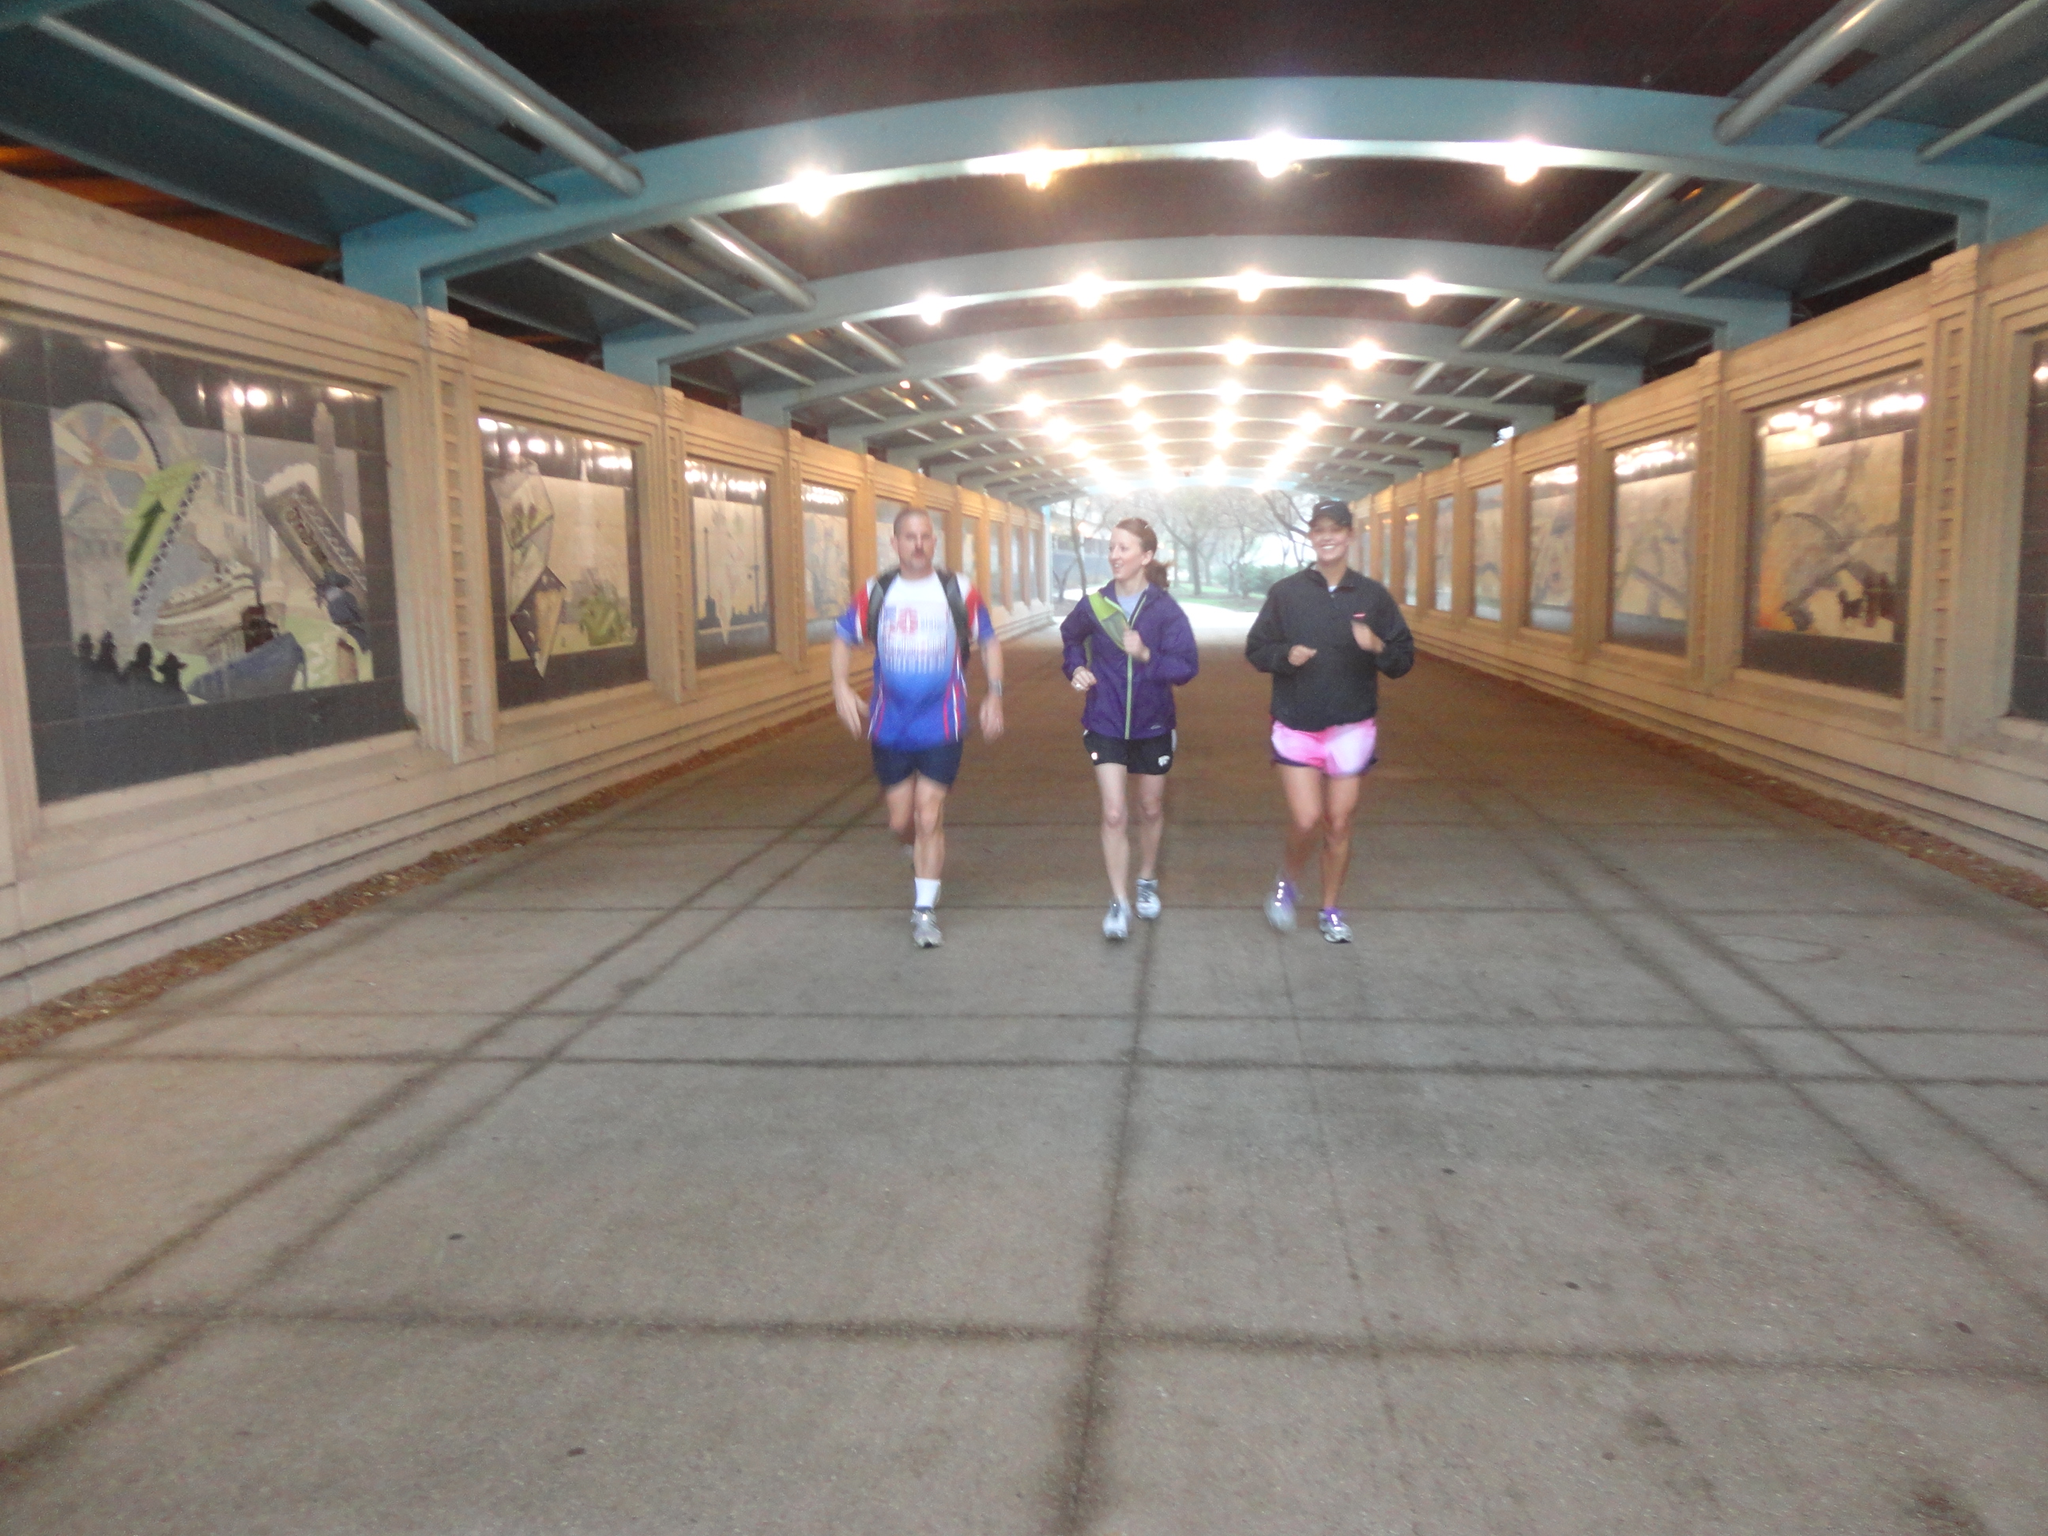In one or two sentences, can you explain what this image depicts? In this image we can see the people running on the ground and the other person holding an object. And we can see the wall with images on both the sides. In the background, we can see the trees and at the top we can see the ceiling with lights. 